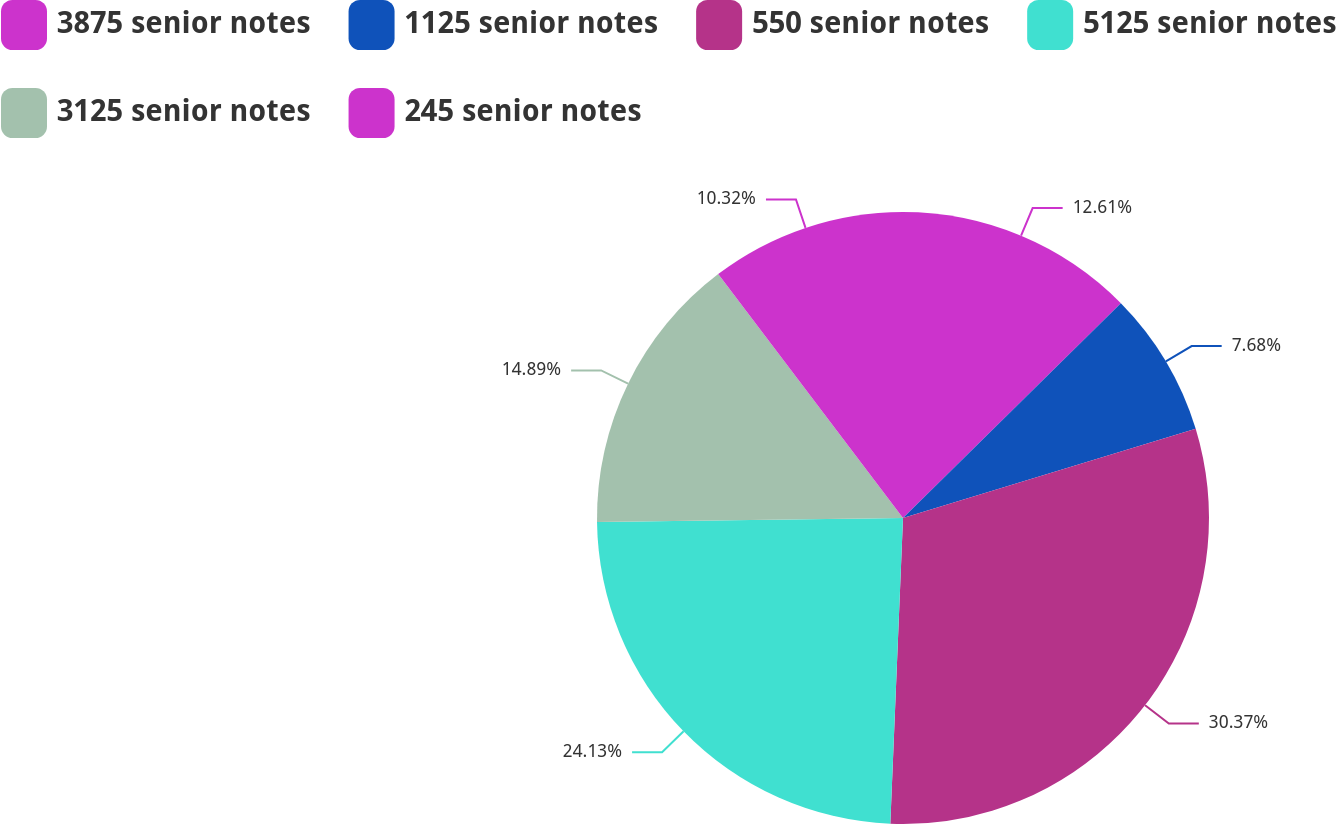Convert chart. <chart><loc_0><loc_0><loc_500><loc_500><pie_chart><fcel>3875 senior notes<fcel>1125 senior notes<fcel>550 senior notes<fcel>5125 senior notes<fcel>3125 senior notes<fcel>245 senior notes<nl><fcel>12.61%<fcel>7.68%<fcel>30.37%<fcel>24.13%<fcel>14.89%<fcel>10.32%<nl></chart> 